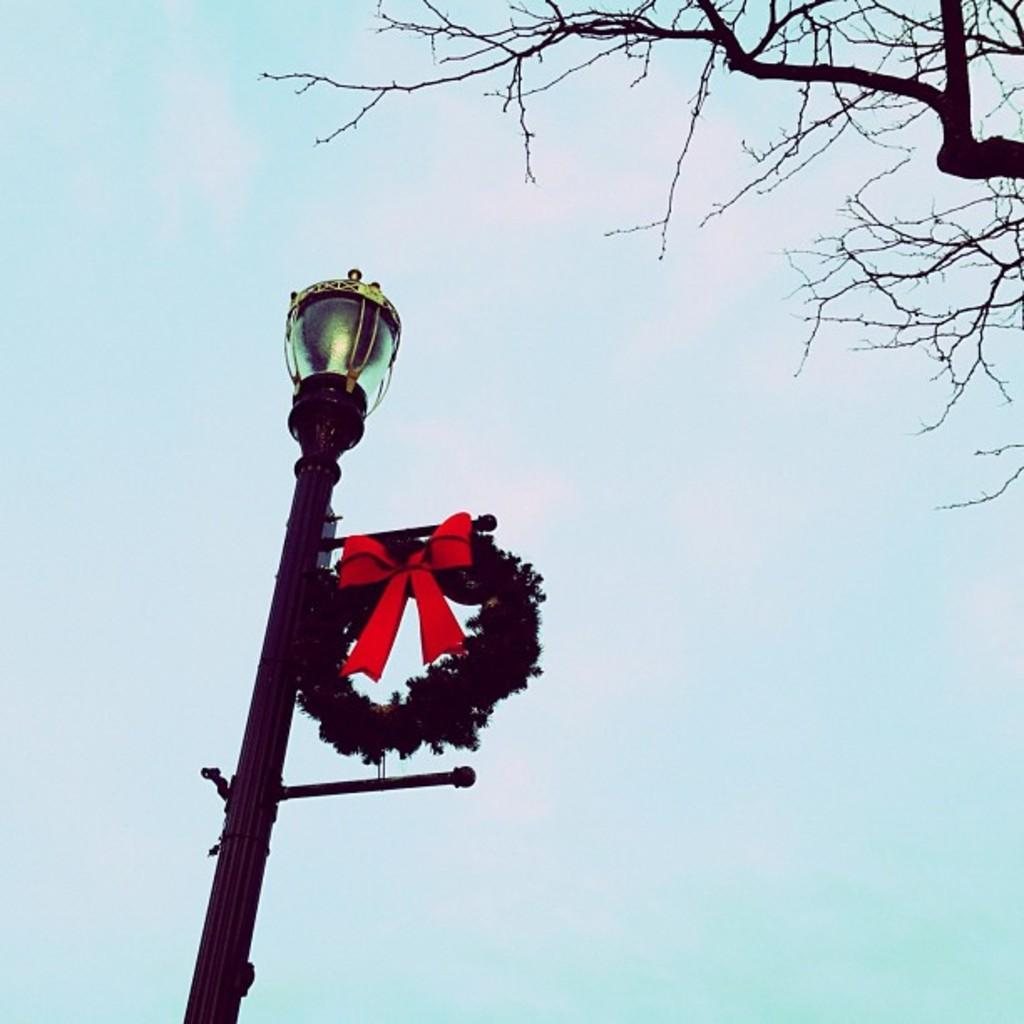What is located on the left side of the image? There is a pole on the left side of the image. What is at the top of the pole? There is a light at the top of the pole. What can be seen in the upper part of the image? There is a tree and the sky visible at the top of the image. What type of fruit is hanging from the pole in the image? There is no fruit hanging from the pole in the image; it only has a light at the top. 